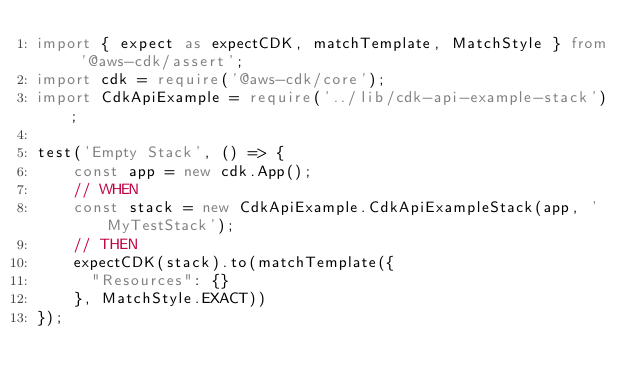Convert code to text. <code><loc_0><loc_0><loc_500><loc_500><_TypeScript_>import { expect as expectCDK, matchTemplate, MatchStyle } from '@aws-cdk/assert';
import cdk = require('@aws-cdk/core');
import CdkApiExample = require('../lib/cdk-api-example-stack');

test('Empty Stack', () => {
    const app = new cdk.App();
    // WHEN
    const stack = new CdkApiExample.CdkApiExampleStack(app, 'MyTestStack');
    // THEN
    expectCDK(stack).to(matchTemplate({
      "Resources": {}
    }, MatchStyle.EXACT))
});</code> 